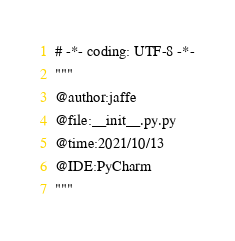<code> <loc_0><loc_0><loc_500><loc_500><_Python_># -*- coding: UTF-8 -*-
"""
@author:jaffe
@file:__init__.py.py
@time:2021/10/13
@IDE:PyCharm 
"""
</code> 